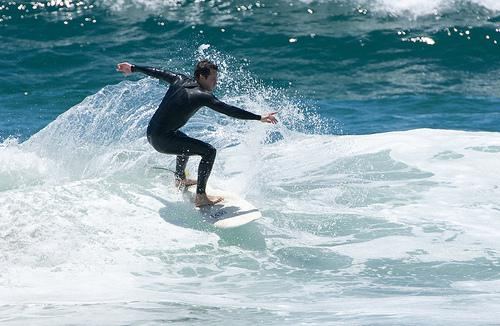Question: why are the man's arms outstretched?
Choices:
A. For balance.
B. To grab something.
C. To hold someone's hand.
D. To catch a ball.
Answer with the letter. Answer: A Question: who is in the picture?
Choices:
A. A swimmer.
B. A runner.
C. A surfer.
D. A volleyball player.
Answer with the letter. Answer: C Question: what is the man standing on?
Choices:
A. The sand.
B. A skateboard.
C. A surfboard.
D. A towel.
Answer with the letter. Answer: C Question: where is this scene?
Choices:
A. The ocean.
B. The pool.
C. The park.
D. The library.
Answer with the letter. Answer: A Question: how is the weather?
Choices:
A. Cloudy.
B. Sunny.
C. Foggy.
D. Rainy.
Answer with the letter. Answer: B 